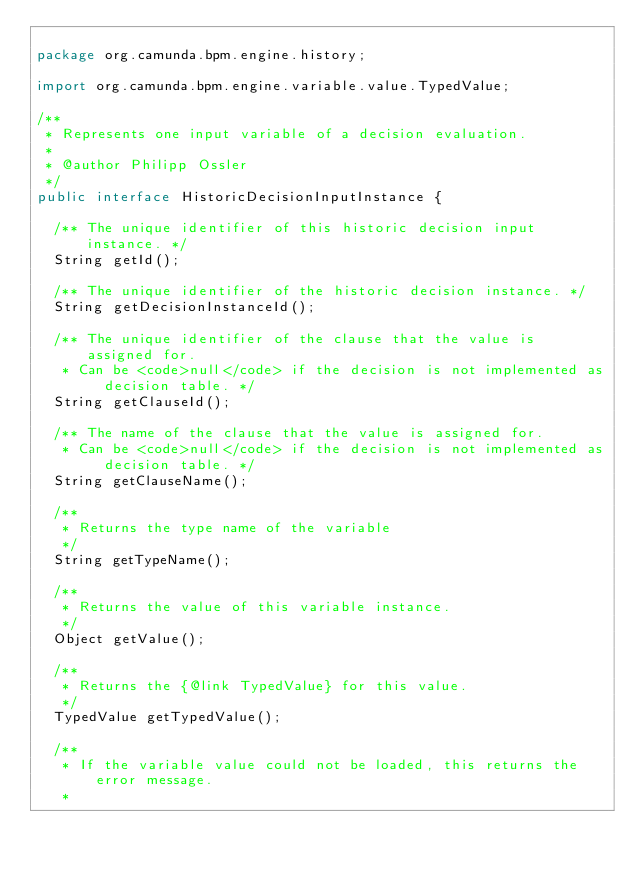Convert code to text. <code><loc_0><loc_0><loc_500><loc_500><_Java_>
package org.camunda.bpm.engine.history;

import org.camunda.bpm.engine.variable.value.TypedValue;

/**
 * Represents one input variable of a decision evaluation.
 *
 * @author Philipp Ossler
 */
public interface HistoricDecisionInputInstance {

  /** The unique identifier of this historic decision input instance. */
  String getId();

  /** The unique identifier of the historic decision instance. */
  String getDecisionInstanceId();

  /** The unique identifier of the clause that the value is assigned for.
   * Can be <code>null</code> if the decision is not implemented as decision table. */
  String getClauseId();

  /** The name of the clause that the value is assigned for.
   * Can be <code>null</code> if the decision is not implemented as decision table. */
  String getClauseName();

  /**
   * Returns the type name of the variable
   */
  String getTypeName();

  /**
   * Returns the value of this variable instance.
   */
  Object getValue();

  /**
   * Returns the {@link TypedValue} for this value.
   */
  TypedValue getTypedValue();

  /**
   * If the variable value could not be loaded, this returns the error message.
   *</code> 